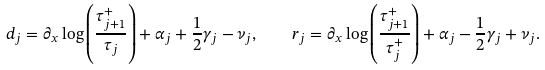<formula> <loc_0><loc_0><loc_500><loc_500>d _ { j } = \partial _ { x } \log \left ( \frac { \tau _ { j + 1 } ^ { + } } { \tau _ { j } } \right ) + \alpha _ { j } + \frac { 1 } { 2 } \gamma _ { j } - \nu _ { j } , \quad r _ { j } = \partial _ { x } \log \left ( \frac { \tau _ { j + 1 } ^ { + } } { \tau _ { j } ^ { + } } \right ) + \alpha _ { j } - \frac { 1 } { 2 } \gamma _ { j } + \nu _ { j } .</formula> 